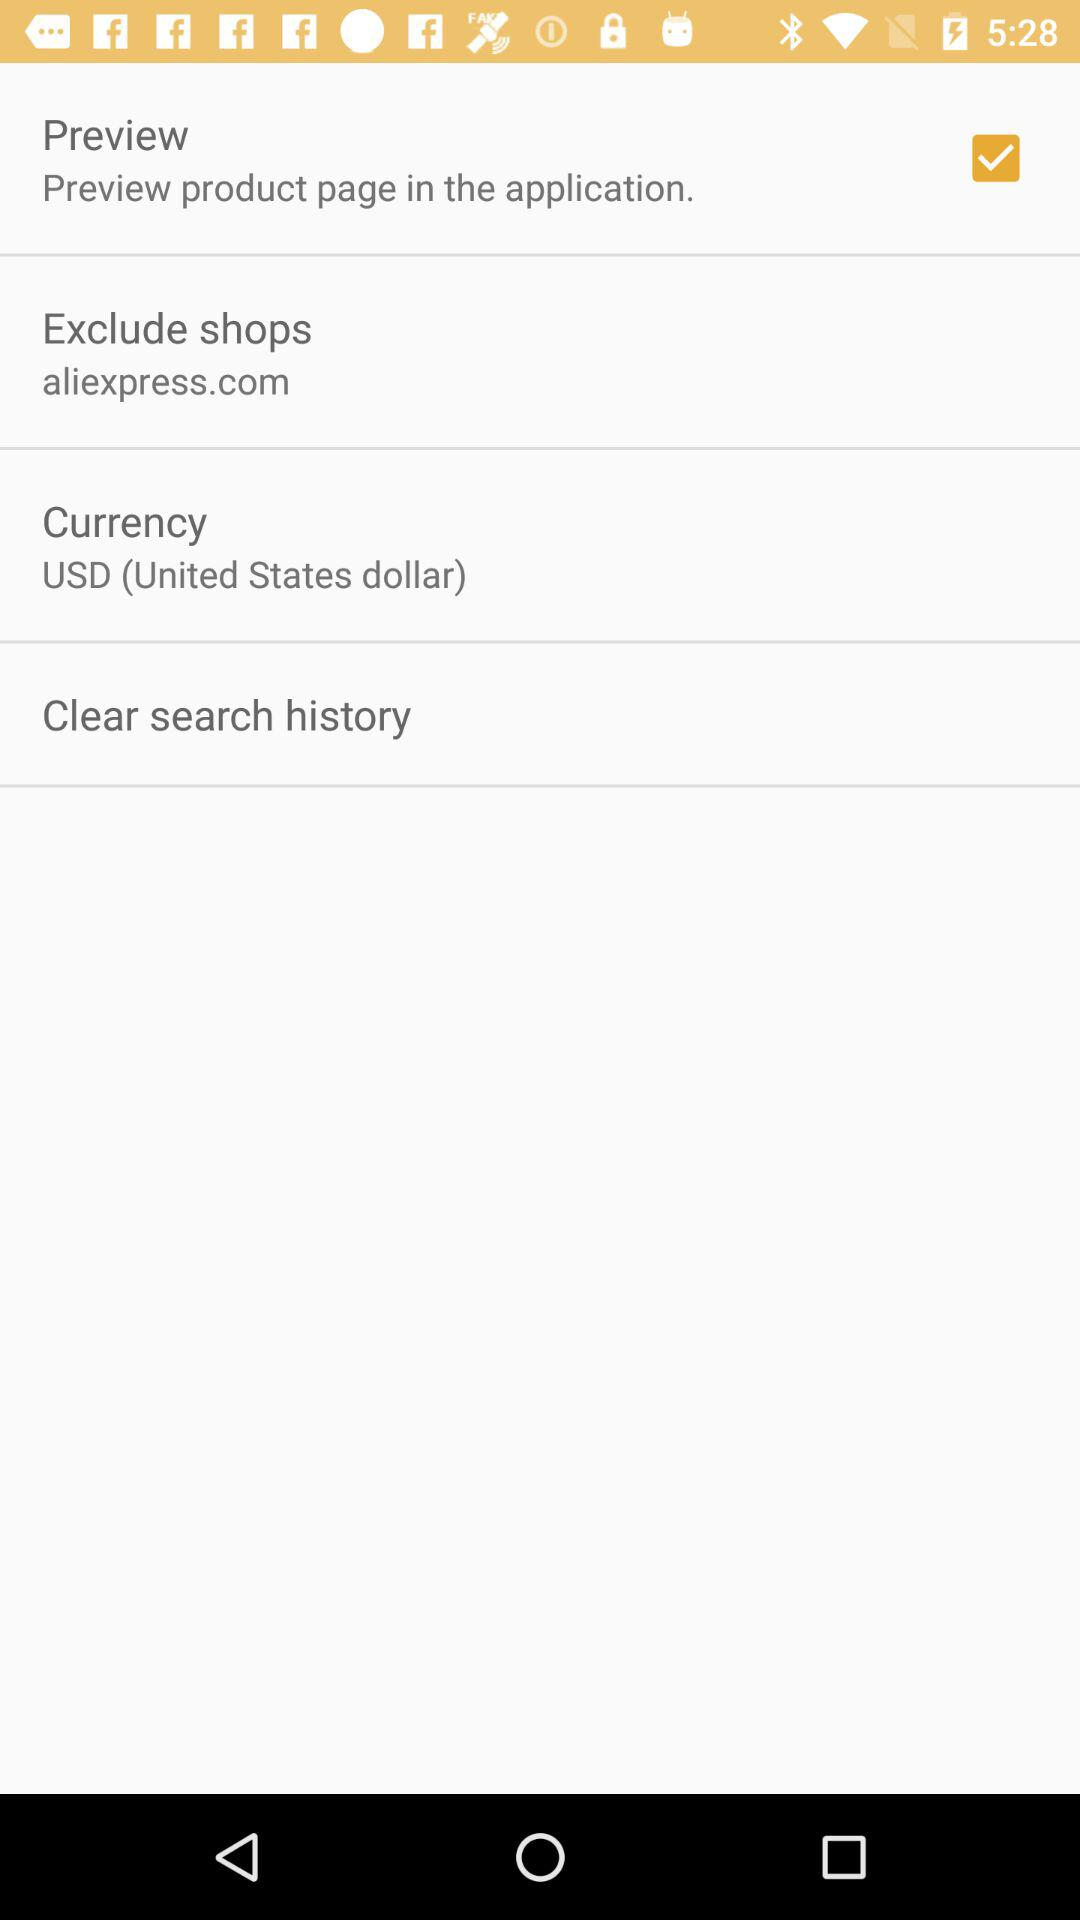What is the status of the currency? The status is "USD (United States dollar)". 